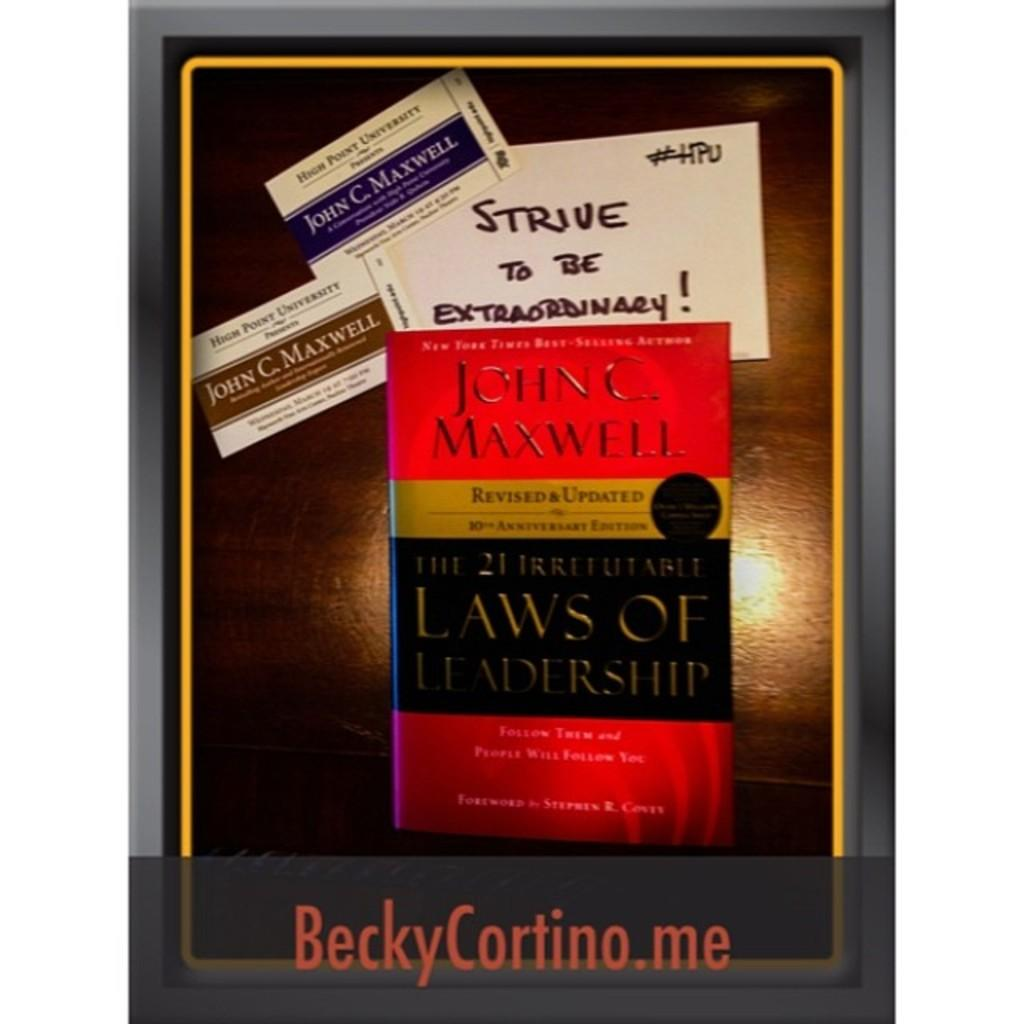<image>
Relay a brief, clear account of the picture shown. Two business cards and a book on leadership by John C. Maxwell 